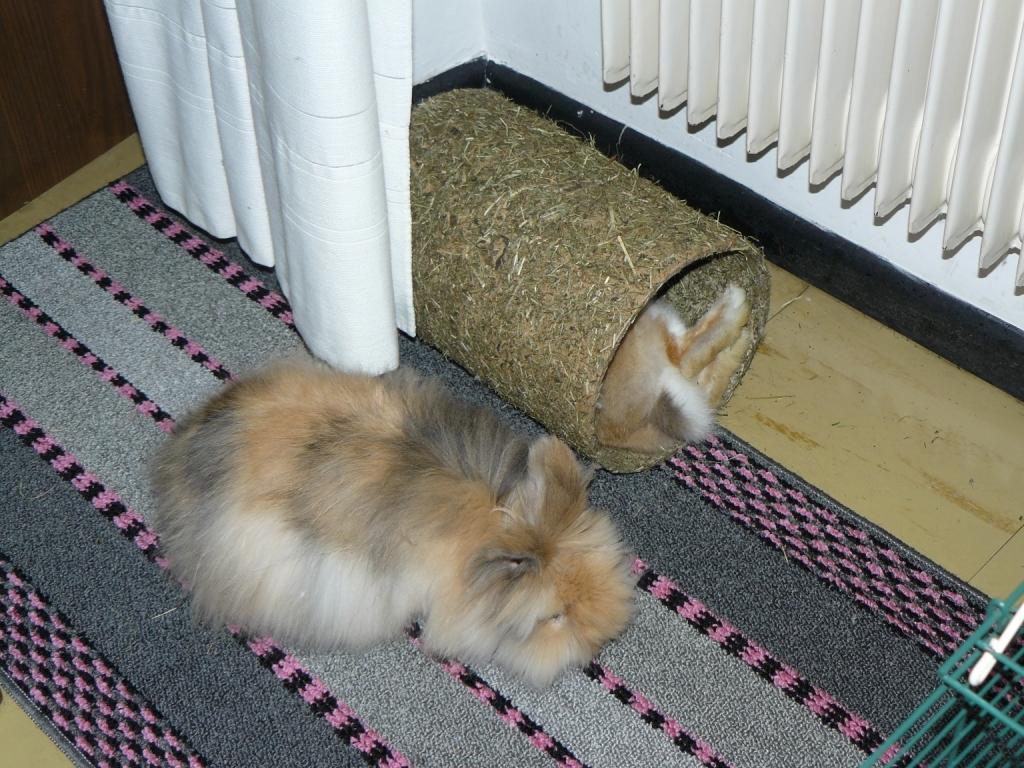Could you give a brief overview of what you see in this image? At the bottom of the picture, we see a domestic animal which looks like a dog is on the doormat. Beside that, we see a white curtain and beside that, we see a domestic animal in the round cardboard core. In the right top of the picture, we see a white wall and a white curtain. In the left top of the picture, we see a brown color door. This picture is clicked inside the room. 